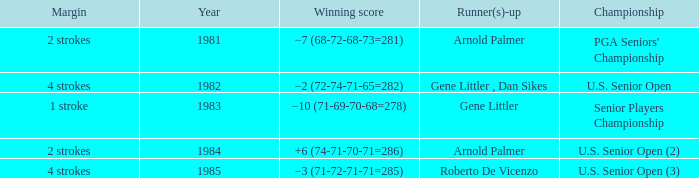What margin was in after 1981, and was Roberto De Vicenzo runner-up? 4 strokes. 